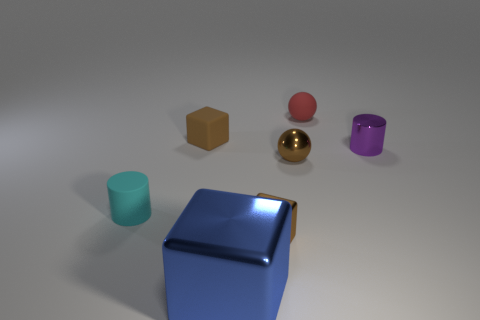Subtract all rubber blocks. How many blocks are left? 2 Subtract 1 cubes. How many cubes are left? 2 Add 7 small metallic cylinders. How many small metallic cylinders exist? 8 Add 3 small blue shiny cubes. How many objects exist? 10 Subtract all blue blocks. How many blocks are left? 2 Subtract 0 cyan cubes. How many objects are left? 7 Subtract all spheres. How many objects are left? 5 Subtract all red spheres. Subtract all cyan cylinders. How many spheres are left? 1 Subtract all purple cylinders. How many gray spheres are left? 0 Subtract all tiny red spheres. Subtract all cylinders. How many objects are left? 4 